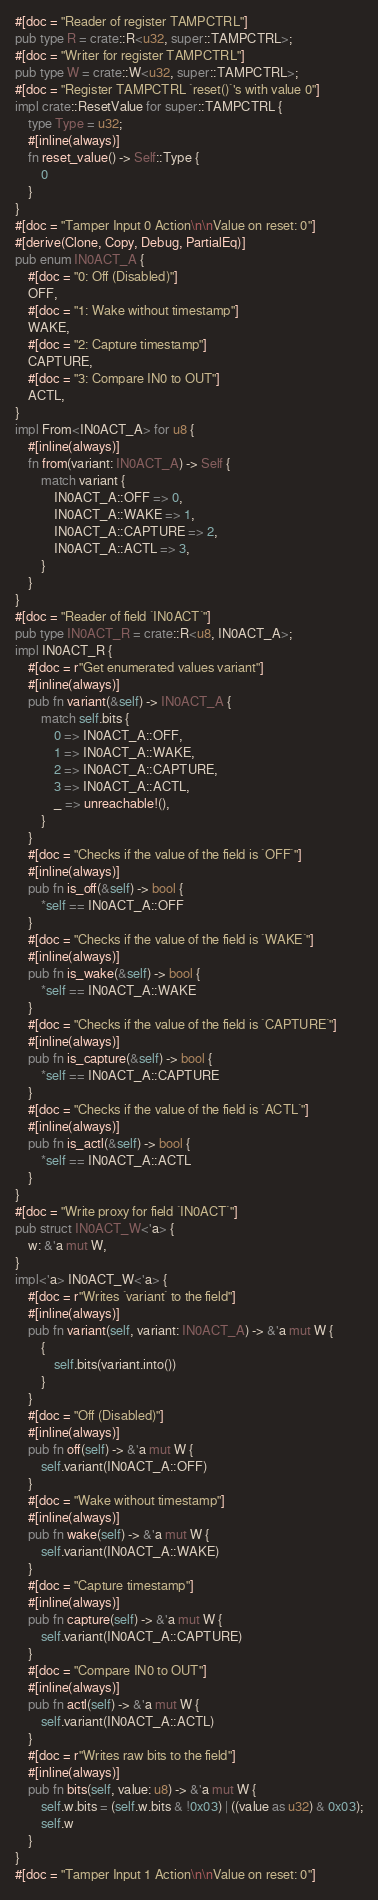Convert code to text. <code><loc_0><loc_0><loc_500><loc_500><_Rust_>#[doc = "Reader of register TAMPCTRL"]
pub type R = crate::R<u32, super::TAMPCTRL>;
#[doc = "Writer for register TAMPCTRL"]
pub type W = crate::W<u32, super::TAMPCTRL>;
#[doc = "Register TAMPCTRL `reset()`'s with value 0"]
impl crate::ResetValue for super::TAMPCTRL {
    type Type = u32;
    #[inline(always)]
    fn reset_value() -> Self::Type {
        0
    }
}
#[doc = "Tamper Input 0 Action\n\nValue on reset: 0"]
#[derive(Clone, Copy, Debug, PartialEq)]
pub enum IN0ACT_A {
    #[doc = "0: Off (Disabled)"]
    OFF,
    #[doc = "1: Wake without timestamp"]
    WAKE,
    #[doc = "2: Capture timestamp"]
    CAPTURE,
    #[doc = "3: Compare IN0 to OUT"]
    ACTL,
}
impl From<IN0ACT_A> for u8 {
    #[inline(always)]
    fn from(variant: IN0ACT_A) -> Self {
        match variant {
            IN0ACT_A::OFF => 0,
            IN0ACT_A::WAKE => 1,
            IN0ACT_A::CAPTURE => 2,
            IN0ACT_A::ACTL => 3,
        }
    }
}
#[doc = "Reader of field `IN0ACT`"]
pub type IN0ACT_R = crate::R<u8, IN0ACT_A>;
impl IN0ACT_R {
    #[doc = r"Get enumerated values variant"]
    #[inline(always)]
    pub fn variant(&self) -> IN0ACT_A {
        match self.bits {
            0 => IN0ACT_A::OFF,
            1 => IN0ACT_A::WAKE,
            2 => IN0ACT_A::CAPTURE,
            3 => IN0ACT_A::ACTL,
            _ => unreachable!(),
        }
    }
    #[doc = "Checks if the value of the field is `OFF`"]
    #[inline(always)]
    pub fn is_off(&self) -> bool {
        *self == IN0ACT_A::OFF
    }
    #[doc = "Checks if the value of the field is `WAKE`"]
    #[inline(always)]
    pub fn is_wake(&self) -> bool {
        *self == IN0ACT_A::WAKE
    }
    #[doc = "Checks if the value of the field is `CAPTURE`"]
    #[inline(always)]
    pub fn is_capture(&self) -> bool {
        *self == IN0ACT_A::CAPTURE
    }
    #[doc = "Checks if the value of the field is `ACTL`"]
    #[inline(always)]
    pub fn is_actl(&self) -> bool {
        *self == IN0ACT_A::ACTL
    }
}
#[doc = "Write proxy for field `IN0ACT`"]
pub struct IN0ACT_W<'a> {
    w: &'a mut W,
}
impl<'a> IN0ACT_W<'a> {
    #[doc = r"Writes `variant` to the field"]
    #[inline(always)]
    pub fn variant(self, variant: IN0ACT_A) -> &'a mut W {
        {
            self.bits(variant.into())
        }
    }
    #[doc = "Off (Disabled)"]
    #[inline(always)]
    pub fn off(self) -> &'a mut W {
        self.variant(IN0ACT_A::OFF)
    }
    #[doc = "Wake without timestamp"]
    #[inline(always)]
    pub fn wake(self) -> &'a mut W {
        self.variant(IN0ACT_A::WAKE)
    }
    #[doc = "Capture timestamp"]
    #[inline(always)]
    pub fn capture(self) -> &'a mut W {
        self.variant(IN0ACT_A::CAPTURE)
    }
    #[doc = "Compare IN0 to OUT"]
    #[inline(always)]
    pub fn actl(self) -> &'a mut W {
        self.variant(IN0ACT_A::ACTL)
    }
    #[doc = r"Writes raw bits to the field"]
    #[inline(always)]
    pub fn bits(self, value: u8) -> &'a mut W {
        self.w.bits = (self.w.bits & !0x03) | ((value as u32) & 0x03);
        self.w
    }
}
#[doc = "Tamper Input 1 Action\n\nValue on reset: 0"]</code> 